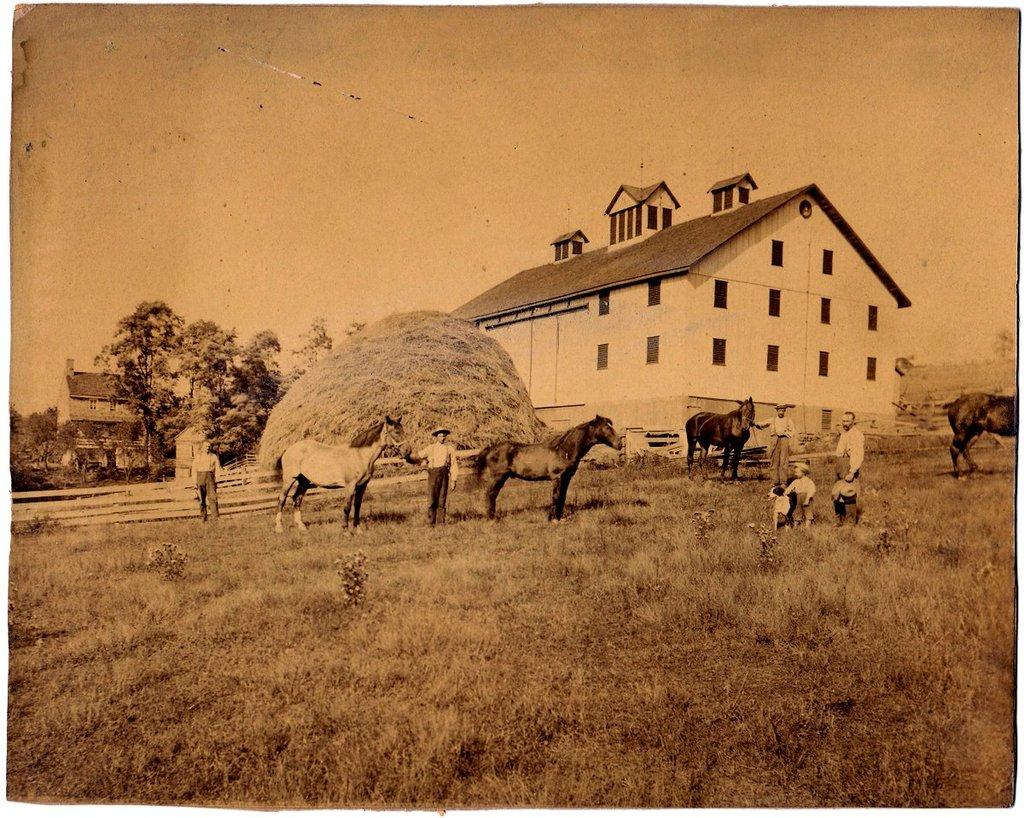How many men are present in the image? There are four men in the image. What other subjects can be seen in the image besides the men? There are kids and horses in the image. Where are the subjects located in the image? The subjects are standing on the ground. What can be seen in the background of the image? There are buildings, trees, a fence, windows, and the sky visible in the background of the image. Where is the monkey sitting on a throne in the image? There is no monkey or throne present in the image. How many deer can be seen grazing in the background of the image? There are no deer visible in the image. 